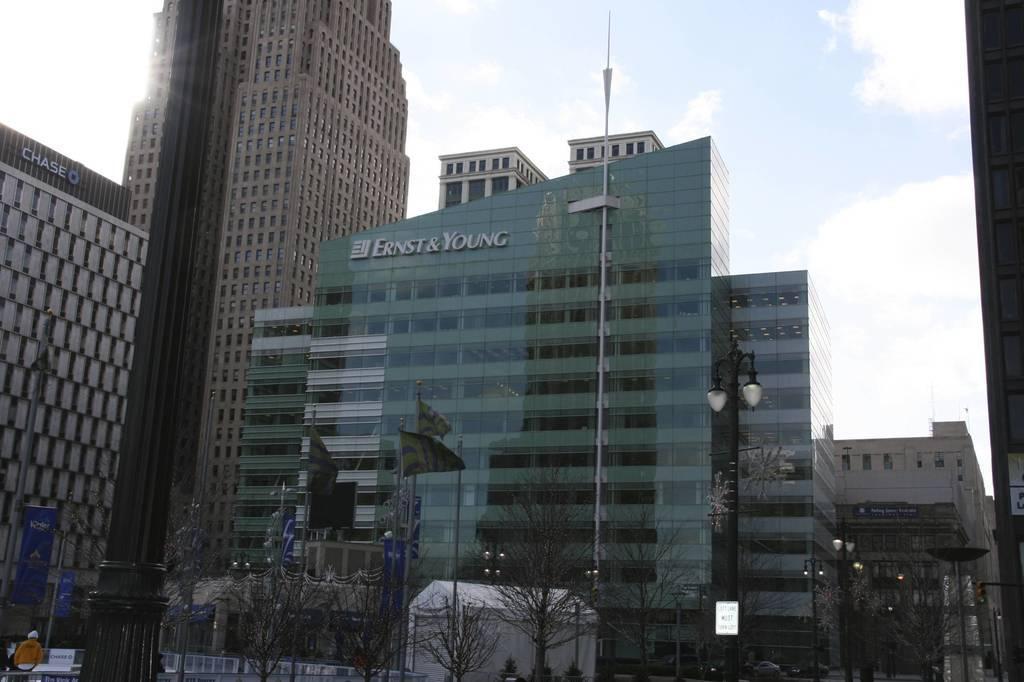In one or two sentences, can you explain what this image depicts? In this picture we can see buildings, poles, lights, trees, flags, boards, and banners. In the background there is sky with clouds. 